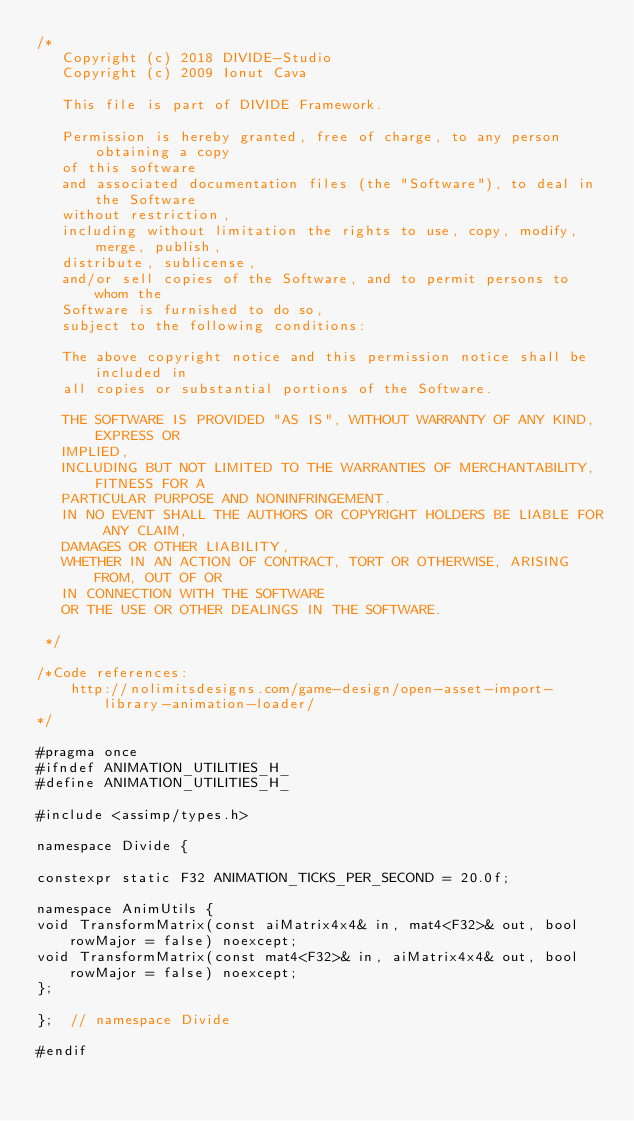Convert code to text. <code><loc_0><loc_0><loc_500><loc_500><_C_>/*
   Copyright (c) 2018 DIVIDE-Studio
   Copyright (c) 2009 Ionut Cava

   This file is part of DIVIDE Framework.

   Permission is hereby granted, free of charge, to any person obtaining a copy
   of this software
   and associated documentation files (the "Software"), to deal in the Software
   without restriction,
   including without limitation the rights to use, copy, modify, merge, publish,
   distribute, sublicense,
   and/or sell copies of the Software, and to permit persons to whom the
   Software is furnished to do so,
   subject to the following conditions:

   The above copyright notice and this permission notice shall be included in
   all copies or substantial portions of the Software.

   THE SOFTWARE IS PROVIDED "AS IS", WITHOUT WARRANTY OF ANY KIND, EXPRESS OR
   IMPLIED,
   INCLUDING BUT NOT LIMITED TO THE WARRANTIES OF MERCHANTABILITY, FITNESS FOR A
   PARTICULAR PURPOSE AND NONINFRINGEMENT.
   IN NO EVENT SHALL THE AUTHORS OR COPYRIGHT HOLDERS BE LIABLE FOR ANY CLAIM,
   DAMAGES OR OTHER LIABILITY,
   WHETHER IN AN ACTION OF CONTRACT, TORT OR OTHERWISE, ARISING FROM, OUT OF OR
   IN CONNECTION WITH THE SOFTWARE
   OR THE USE OR OTHER DEALINGS IN THE SOFTWARE.

 */

/*Code references:
    http://nolimitsdesigns.com/game-design/open-asset-import-library-animation-loader/
*/

#pragma once
#ifndef ANIMATION_UTILITIES_H_
#define ANIMATION_UTILITIES_H_

#include <assimp/types.h>

namespace Divide {

constexpr static F32 ANIMATION_TICKS_PER_SECOND = 20.0f;

namespace AnimUtils {
void TransformMatrix(const aiMatrix4x4& in, mat4<F32>& out, bool rowMajor = false) noexcept;
void TransformMatrix(const mat4<F32>& in, aiMatrix4x4& out, bool rowMajor = false) noexcept;
};

};  // namespace Divide

#endif</code> 